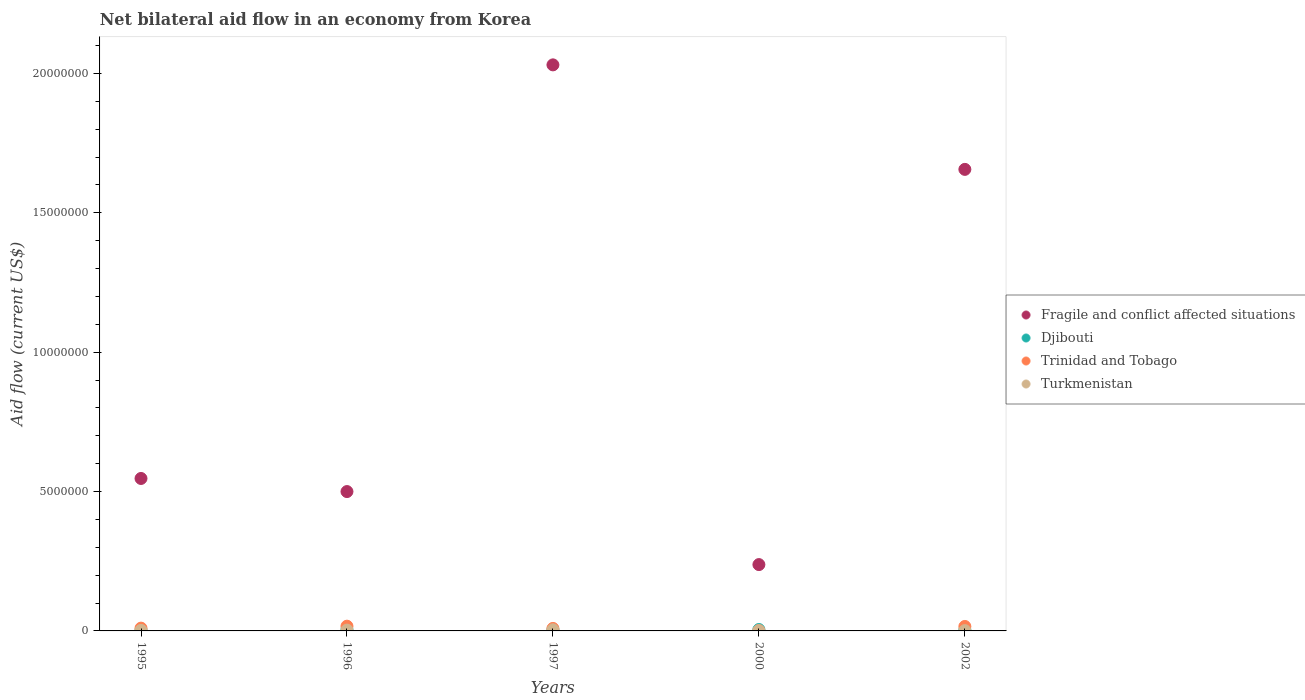How many different coloured dotlines are there?
Provide a succinct answer. 4. Across all years, what is the maximum net bilateral aid flow in Turkmenistan?
Keep it short and to the point. 4.00e+04. In which year was the net bilateral aid flow in Turkmenistan maximum?
Make the answer very short. 1997. What is the difference between the net bilateral aid flow in Fragile and conflict affected situations in 1995 and that in 2000?
Your answer should be compact. 3.09e+06. What is the average net bilateral aid flow in Fragile and conflict affected situations per year?
Provide a short and direct response. 9.94e+06. In the year 1997, what is the difference between the net bilateral aid flow in Djibouti and net bilateral aid flow in Fragile and conflict affected situations?
Your answer should be compact. -2.03e+07. In how many years, is the net bilateral aid flow in Trinidad and Tobago greater than 8000000 US$?
Give a very brief answer. 0. What is the difference between the highest and the second highest net bilateral aid flow in Djibouti?
Give a very brief answer. 0. What is the difference between the highest and the lowest net bilateral aid flow in Fragile and conflict affected situations?
Your answer should be compact. 1.79e+07. Is it the case that in every year, the sum of the net bilateral aid flow in Turkmenistan and net bilateral aid flow in Trinidad and Tobago  is greater than the sum of net bilateral aid flow in Fragile and conflict affected situations and net bilateral aid flow in Djibouti?
Your answer should be compact. No. Does the net bilateral aid flow in Trinidad and Tobago monotonically increase over the years?
Your answer should be very brief. No. Is the net bilateral aid flow in Trinidad and Tobago strictly greater than the net bilateral aid flow in Fragile and conflict affected situations over the years?
Give a very brief answer. No. How many years are there in the graph?
Provide a succinct answer. 5. Are the values on the major ticks of Y-axis written in scientific E-notation?
Ensure brevity in your answer.  No. Does the graph contain grids?
Keep it short and to the point. No. Where does the legend appear in the graph?
Your response must be concise. Center right. How many legend labels are there?
Make the answer very short. 4. How are the legend labels stacked?
Give a very brief answer. Vertical. What is the title of the graph?
Provide a short and direct response. Net bilateral aid flow in an economy from Korea. Does "Moldova" appear as one of the legend labels in the graph?
Your answer should be very brief. No. What is the label or title of the Y-axis?
Your response must be concise. Aid flow (current US$). What is the Aid flow (current US$) in Fragile and conflict affected situations in 1995?
Your response must be concise. 5.47e+06. What is the Aid flow (current US$) of Djibouti in 1995?
Offer a very short reply. 3.00e+04. What is the Aid flow (current US$) in Trinidad and Tobago in 1995?
Your answer should be very brief. 1.00e+05. What is the Aid flow (current US$) in Fragile and conflict affected situations in 1996?
Provide a short and direct response. 5.00e+06. What is the Aid flow (current US$) of Djibouti in 1996?
Make the answer very short. 5.00e+04. What is the Aid flow (current US$) in Fragile and conflict affected situations in 1997?
Offer a very short reply. 2.03e+07. What is the Aid flow (current US$) of Trinidad and Tobago in 1997?
Make the answer very short. 9.00e+04. What is the Aid flow (current US$) of Fragile and conflict affected situations in 2000?
Offer a very short reply. 2.38e+06. What is the Aid flow (current US$) in Fragile and conflict affected situations in 2002?
Your answer should be very brief. 1.66e+07. What is the Aid flow (current US$) in Djibouti in 2002?
Make the answer very short. 4.00e+04. What is the Aid flow (current US$) in Trinidad and Tobago in 2002?
Offer a very short reply. 1.60e+05. Across all years, what is the maximum Aid flow (current US$) in Fragile and conflict affected situations?
Give a very brief answer. 2.03e+07. Across all years, what is the maximum Aid flow (current US$) in Turkmenistan?
Your answer should be compact. 4.00e+04. Across all years, what is the minimum Aid flow (current US$) of Fragile and conflict affected situations?
Make the answer very short. 2.38e+06. Across all years, what is the minimum Aid flow (current US$) in Djibouti?
Offer a very short reply. 3.00e+04. Across all years, what is the minimum Aid flow (current US$) of Trinidad and Tobago?
Provide a succinct answer. 10000. Across all years, what is the minimum Aid flow (current US$) of Turkmenistan?
Your answer should be very brief. 10000. What is the total Aid flow (current US$) of Fragile and conflict affected situations in the graph?
Provide a short and direct response. 4.97e+07. What is the total Aid flow (current US$) of Trinidad and Tobago in the graph?
Offer a terse response. 5.30e+05. What is the difference between the Aid flow (current US$) of Fragile and conflict affected situations in 1995 and that in 1996?
Offer a very short reply. 4.70e+05. What is the difference between the Aid flow (current US$) of Djibouti in 1995 and that in 1996?
Give a very brief answer. -2.00e+04. What is the difference between the Aid flow (current US$) of Turkmenistan in 1995 and that in 1996?
Offer a very short reply. -10000. What is the difference between the Aid flow (current US$) of Fragile and conflict affected situations in 1995 and that in 1997?
Your answer should be compact. -1.48e+07. What is the difference between the Aid flow (current US$) in Djibouti in 1995 and that in 1997?
Make the answer very short. -10000. What is the difference between the Aid flow (current US$) of Fragile and conflict affected situations in 1995 and that in 2000?
Give a very brief answer. 3.09e+06. What is the difference between the Aid flow (current US$) of Djibouti in 1995 and that in 2000?
Give a very brief answer. -2.00e+04. What is the difference between the Aid flow (current US$) in Trinidad and Tobago in 1995 and that in 2000?
Your answer should be very brief. 9.00e+04. What is the difference between the Aid flow (current US$) of Fragile and conflict affected situations in 1995 and that in 2002?
Provide a short and direct response. -1.11e+07. What is the difference between the Aid flow (current US$) in Turkmenistan in 1995 and that in 2002?
Ensure brevity in your answer.  10000. What is the difference between the Aid flow (current US$) in Fragile and conflict affected situations in 1996 and that in 1997?
Ensure brevity in your answer.  -1.53e+07. What is the difference between the Aid flow (current US$) of Turkmenistan in 1996 and that in 1997?
Give a very brief answer. -10000. What is the difference between the Aid flow (current US$) in Fragile and conflict affected situations in 1996 and that in 2000?
Offer a very short reply. 2.62e+06. What is the difference between the Aid flow (current US$) of Trinidad and Tobago in 1996 and that in 2000?
Provide a succinct answer. 1.60e+05. What is the difference between the Aid flow (current US$) in Turkmenistan in 1996 and that in 2000?
Your answer should be very brief. 2.00e+04. What is the difference between the Aid flow (current US$) in Fragile and conflict affected situations in 1996 and that in 2002?
Provide a succinct answer. -1.16e+07. What is the difference between the Aid flow (current US$) of Djibouti in 1996 and that in 2002?
Your answer should be very brief. 10000. What is the difference between the Aid flow (current US$) in Trinidad and Tobago in 1996 and that in 2002?
Ensure brevity in your answer.  10000. What is the difference between the Aid flow (current US$) of Fragile and conflict affected situations in 1997 and that in 2000?
Your answer should be compact. 1.79e+07. What is the difference between the Aid flow (current US$) of Djibouti in 1997 and that in 2000?
Offer a terse response. -10000. What is the difference between the Aid flow (current US$) in Trinidad and Tobago in 1997 and that in 2000?
Your answer should be very brief. 8.00e+04. What is the difference between the Aid flow (current US$) in Fragile and conflict affected situations in 1997 and that in 2002?
Provide a succinct answer. 3.75e+06. What is the difference between the Aid flow (current US$) of Turkmenistan in 1997 and that in 2002?
Keep it short and to the point. 3.00e+04. What is the difference between the Aid flow (current US$) of Fragile and conflict affected situations in 2000 and that in 2002?
Make the answer very short. -1.42e+07. What is the difference between the Aid flow (current US$) of Djibouti in 2000 and that in 2002?
Keep it short and to the point. 10000. What is the difference between the Aid flow (current US$) of Turkmenistan in 2000 and that in 2002?
Provide a succinct answer. 0. What is the difference between the Aid flow (current US$) of Fragile and conflict affected situations in 1995 and the Aid flow (current US$) of Djibouti in 1996?
Your response must be concise. 5.42e+06. What is the difference between the Aid flow (current US$) of Fragile and conflict affected situations in 1995 and the Aid flow (current US$) of Trinidad and Tobago in 1996?
Offer a terse response. 5.30e+06. What is the difference between the Aid flow (current US$) of Fragile and conflict affected situations in 1995 and the Aid flow (current US$) of Turkmenistan in 1996?
Give a very brief answer. 5.44e+06. What is the difference between the Aid flow (current US$) of Fragile and conflict affected situations in 1995 and the Aid flow (current US$) of Djibouti in 1997?
Your answer should be compact. 5.43e+06. What is the difference between the Aid flow (current US$) of Fragile and conflict affected situations in 1995 and the Aid flow (current US$) of Trinidad and Tobago in 1997?
Provide a succinct answer. 5.38e+06. What is the difference between the Aid flow (current US$) of Fragile and conflict affected situations in 1995 and the Aid flow (current US$) of Turkmenistan in 1997?
Ensure brevity in your answer.  5.43e+06. What is the difference between the Aid flow (current US$) in Djibouti in 1995 and the Aid flow (current US$) in Trinidad and Tobago in 1997?
Your answer should be compact. -6.00e+04. What is the difference between the Aid flow (current US$) in Djibouti in 1995 and the Aid flow (current US$) in Turkmenistan in 1997?
Make the answer very short. -10000. What is the difference between the Aid flow (current US$) of Trinidad and Tobago in 1995 and the Aid flow (current US$) of Turkmenistan in 1997?
Provide a succinct answer. 6.00e+04. What is the difference between the Aid flow (current US$) in Fragile and conflict affected situations in 1995 and the Aid flow (current US$) in Djibouti in 2000?
Your answer should be compact. 5.42e+06. What is the difference between the Aid flow (current US$) of Fragile and conflict affected situations in 1995 and the Aid flow (current US$) of Trinidad and Tobago in 2000?
Give a very brief answer. 5.46e+06. What is the difference between the Aid flow (current US$) of Fragile and conflict affected situations in 1995 and the Aid flow (current US$) of Turkmenistan in 2000?
Give a very brief answer. 5.46e+06. What is the difference between the Aid flow (current US$) in Trinidad and Tobago in 1995 and the Aid flow (current US$) in Turkmenistan in 2000?
Make the answer very short. 9.00e+04. What is the difference between the Aid flow (current US$) in Fragile and conflict affected situations in 1995 and the Aid flow (current US$) in Djibouti in 2002?
Make the answer very short. 5.43e+06. What is the difference between the Aid flow (current US$) in Fragile and conflict affected situations in 1995 and the Aid flow (current US$) in Trinidad and Tobago in 2002?
Give a very brief answer. 5.31e+06. What is the difference between the Aid flow (current US$) of Fragile and conflict affected situations in 1995 and the Aid flow (current US$) of Turkmenistan in 2002?
Your response must be concise. 5.46e+06. What is the difference between the Aid flow (current US$) in Trinidad and Tobago in 1995 and the Aid flow (current US$) in Turkmenistan in 2002?
Make the answer very short. 9.00e+04. What is the difference between the Aid flow (current US$) in Fragile and conflict affected situations in 1996 and the Aid flow (current US$) in Djibouti in 1997?
Your response must be concise. 4.96e+06. What is the difference between the Aid flow (current US$) of Fragile and conflict affected situations in 1996 and the Aid flow (current US$) of Trinidad and Tobago in 1997?
Offer a terse response. 4.91e+06. What is the difference between the Aid flow (current US$) of Fragile and conflict affected situations in 1996 and the Aid flow (current US$) of Turkmenistan in 1997?
Provide a short and direct response. 4.96e+06. What is the difference between the Aid flow (current US$) in Djibouti in 1996 and the Aid flow (current US$) in Turkmenistan in 1997?
Provide a succinct answer. 10000. What is the difference between the Aid flow (current US$) of Fragile and conflict affected situations in 1996 and the Aid flow (current US$) of Djibouti in 2000?
Your answer should be very brief. 4.95e+06. What is the difference between the Aid flow (current US$) of Fragile and conflict affected situations in 1996 and the Aid flow (current US$) of Trinidad and Tobago in 2000?
Ensure brevity in your answer.  4.99e+06. What is the difference between the Aid flow (current US$) of Fragile and conflict affected situations in 1996 and the Aid flow (current US$) of Turkmenistan in 2000?
Ensure brevity in your answer.  4.99e+06. What is the difference between the Aid flow (current US$) of Djibouti in 1996 and the Aid flow (current US$) of Trinidad and Tobago in 2000?
Keep it short and to the point. 4.00e+04. What is the difference between the Aid flow (current US$) of Trinidad and Tobago in 1996 and the Aid flow (current US$) of Turkmenistan in 2000?
Make the answer very short. 1.60e+05. What is the difference between the Aid flow (current US$) of Fragile and conflict affected situations in 1996 and the Aid flow (current US$) of Djibouti in 2002?
Your response must be concise. 4.96e+06. What is the difference between the Aid flow (current US$) of Fragile and conflict affected situations in 1996 and the Aid flow (current US$) of Trinidad and Tobago in 2002?
Provide a succinct answer. 4.84e+06. What is the difference between the Aid flow (current US$) in Fragile and conflict affected situations in 1996 and the Aid flow (current US$) in Turkmenistan in 2002?
Ensure brevity in your answer.  4.99e+06. What is the difference between the Aid flow (current US$) in Djibouti in 1996 and the Aid flow (current US$) in Trinidad and Tobago in 2002?
Offer a very short reply. -1.10e+05. What is the difference between the Aid flow (current US$) of Djibouti in 1996 and the Aid flow (current US$) of Turkmenistan in 2002?
Make the answer very short. 4.00e+04. What is the difference between the Aid flow (current US$) of Trinidad and Tobago in 1996 and the Aid flow (current US$) of Turkmenistan in 2002?
Give a very brief answer. 1.60e+05. What is the difference between the Aid flow (current US$) in Fragile and conflict affected situations in 1997 and the Aid flow (current US$) in Djibouti in 2000?
Provide a succinct answer. 2.03e+07. What is the difference between the Aid flow (current US$) in Fragile and conflict affected situations in 1997 and the Aid flow (current US$) in Trinidad and Tobago in 2000?
Make the answer very short. 2.03e+07. What is the difference between the Aid flow (current US$) in Fragile and conflict affected situations in 1997 and the Aid flow (current US$) in Turkmenistan in 2000?
Offer a very short reply. 2.03e+07. What is the difference between the Aid flow (current US$) in Fragile and conflict affected situations in 1997 and the Aid flow (current US$) in Djibouti in 2002?
Give a very brief answer. 2.03e+07. What is the difference between the Aid flow (current US$) in Fragile and conflict affected situations in 1997 and the Aid flow (current US$) in Trinidad and Tobago in 2002?
Make the answer very short. 2.02e+07. What is the difference between the Aid flow (current US$) of Fragile and conflict affected situations in 1997 and the Aid flow (current US$) of Turkmenistan in 2002?
Offer a very short reply. 2.03e+07. What is the difference between the Aid flow (current US$) of Djibouti in 1997 and the Aid flow (current US$) of Trinidad and Tobago in 2002?
Ensure brevity in your answer.  -1.20e+05. What is the difference between the Aid flow (current US$) in Fragile and conflict affected situations in 2000 and the Aid flow (current US$) in Djibouti in 2002?
Your response must be concise. 2.34e+06. What is the difference between the Aid flow (current US$) of Fragile and conflict affected situations in 2000 and the Aid flow (current US$) of Trinidad and Tobago in 2002?
Keep it short and to the point. 2.22e+06. What is the difference between the Aid flow (current US$) of Fragile and conflict affected situations in 2000 and the Aid flow (current US$) of Turkmenistan in 2002?
Give a very brief answer. 2.37e+06. What is the difference between the Aid flow (current US$) of Djibouti in 2000 and the Aid flow (current US$) of Trinidad and Tobago in 2002?
Provide a succinct answer. -1.10e+05. What is the difference between the Aid flow (current US$) in Djibouti in 2000 and the Aid flow (current US$) in Turkmenistan in 2002?
Offer a terse response. 4.00e+04. What is the difference between the Aid flow (current US$) in Trinidad and Tobago in 2000 and the Aid flow (current US$) in Turkmenistan in 2002?
Provide a succinct answer. 0. What is the average Aid flow (current US$) in Fragile and conflict affected situations per year?
Offer a terse response. 9.94e+06. What is the average Aid flow (current US$) in Djibouti per year?
Offer a very short reply. 4.20e+04. What is the average Aid flow (current US$) in Trinidad and Tobago per year?
Offer a terse response. 1.06e+05. What is the average Aid flow (current US$) in Turkmenistan per year?
Ensure brevity in your answer.  2.20e+04. In the year 1995, what is the difference between the Aid flow (current US$) of Fragile and conflict affected situations and Aid flow (current US$) of Djibouti?
Make the answer very short. 5.44e+06. In the year 1995, what is the difference between the Aid flow (current US$) in Fragile and conflict affected situations and Aid flow (current US$) in Trinidad and Tobago?
Your answer should be very brief. 5.37e+06. In the year 1995, what is the difference between the Aid flow (current US$) of Fragile and conflict affected situations and Aid flow (current US$) of Turkmenistan?
Provide a short and direct response. 5.45e+06. In the year 1995, what is the difference between the Aid flow (current US$) in Djibouti and Aid flow (current US$) in Trinidad and Tobago?
Ensure brevity in your answer.  -7.00e+04. In the year 1996, what is the difference between the Aid flow (current US$) of Fragile and conflict affected situations and Aid flow (current US$) of Djibouti?
Provide a short and direct response. 4.95e+06. In the year 1996, what is the difference between the Aid flow (current US$) of Fragile and conflict affected situations and Aid flow (current US$) of Trinidad and Tobago?
Provide a short and direct response. 4.83e+06. In the year 1996, what is the difference between the Aid flow (current US$) of Fragile and conflict affected situations and Aid flow (current US$) of Turkmenistan?
Your response must be concise. 4.97e+06. In the year 1996, what is the difference between the Aid flow (current US$) of Djibouti and Aid flow (current US$) of Turkmenistan?
Provide a short and direct response. 2.00e+04. In the year 1997, what is the difference between the Aid flow (current US$) in Fragile and conflict affected situations and Aid flow (current US$) in Djibouti?
Make the answer very short. 2.03e+07. In the year 1997, what is the difference between the Aid flow (current US$) in Fragile and conflict affected situations and Aid flow (current US$) in Trinidad and Tobago?
Ensure brevity in your answer.  2.02e+07. In the year 1997, what is the difference between the Aid flow (current US$) of Fragile and conflict affected situations and Aid flow (current US$) of Turkmenistan?
Keep it short and to the point. 2.03e+07. In the year 1997, what is the difference between the Aid flow (current US$) in Djibouti and Aid flow (current US$) in Trinidad and Tobago?
Your response must be concise. -5.00e+04. In the year 1997, what is the difference between the Aid flow (current US$) in Djibouti and Aid flow (current US$) in Turkmenistan?
Your answer should be very brief. 0. In the year 2000, what is the difference between the Aid flow (current US$) of Fragile and conflict affected situations and Aid flow (current US$) of Djibouti?
Offer a terse response. 2.33e+06. In the year 2000, what is the difference between the Aid flow (current US$) of Fragile and conflict affected situations and Aid flow (current US$) of Trinidad and Tobago?
Make the answer very short. 2.37e+06. In the year 2000, what is the difference between the Aid flow (current US$) of Fragile and conflict affected situations and Aid flow (current US$) of Turkmenistan?
Your answer should be very brief. 2.37e+06. In the year 2000, what is the difference between the Aid flow (current US$) of Djibouti and Aid flow (current US$) of Trinidad and Tobago?
Keep it short and to the point. 4.00e+04. In the year 2002, what is the difference between the Aid flow (current US$) of Fragile and conflict affected situations and Aid flow (current US$) of Djibouti?
Ensure brevity in your answer.  1.65e+07. In the year 2002, what is the difference between the Aid flow (current US$) of Fragile and conflict affected situations and Aid flow (current US$) of Trinidad and Tobago?
Your answer should be very brief. 1.64e+07. In the year 2002, what is the difference between the Aid flow (current US$) of Fragile and conflict affected situations and Aid flow (current US$) of Turkmenistan?
Ensure brevity in your answer.  1.66e+07. In the year 2002, what is the difference between the Aid flow (current US$) of Djibouti and Aid flow (current US$) of Trinidad and Tobago?
Your response must be concise. -1.20e+05. In the year 2002, what is the difference between the Aid flow (current US$) in Djibouti and Aid flow (current US$) in Turkmenistan?
Ensure brevity in your answer.  3.00e+04. In the year 2002, what is the difference between the Aid flow (current US$) of Trinidad and Tobago and Aid flow (current US$) of Turkmenistan?
Make the answer very short. 1.50e+05. What is the ratio of the Aid flow (current US$) in Fragile and conflict affected situations in 1995 to that in 1996?
Your answer should be compact. 1.09. What is the ratio of the Aid flow (current US$) of Trinidad and Tobago in 1995 to that in 1996?
Your answer should be compact. 0.59. What is the ratio of the Aid flow (current US$) of Fragile and conflict affected situations in 1995 to that in 1997?
Give a very brief answer. 0.27. What is the ratio of the Aid flow (current US$) of Djibouti in 1995 to that in 1997?
Provide a succinct answer. 0.75. What is the ratio of the Aid flow (current US$) in Turkmenistan in 1995 to that in 1997?
Offer a very short reply. 0.5. What is the ratio of the Aid flow (current US$) in Fragile and conflict affected situations in 1995 to that in 2000?
Ensure brevity in your answer.  2.3. What is the ratio of the Aid flow (current US$) of Djibouti in 1995 to that in 2000?
Make the answer very short. 0.6. What is the ratio of the Aid flow (current US$) in Trinidad and Tobago in 1995 to that in 2000?
Offer a terse response. 10. What is the ratio of the Aid flow (current US$) of Fragile and conflict affected situations in 1995 to that in 2002?
Give a very brief answer. 0.33. What is the ratio of the Aid flow (current US$) of Djibouti in 1995 to that in 2002?
Your answer should be compact. 0.75. What is the ratio of the Aid flow (current US$) of Turkmenistan in 1995 to that in 2002?
Offer a very short reply. 2. What is the ratio of the Aid flow (current US$) in Fragile and conflict affected situations in 1996 to that in 1997?
Your answer should be very brief. 0.25. What is the ratio of the Aid flow (current US$) of Djibouti in 1996 to that in 1997?
Ensure brevity in your answer.  1.25. What is the ratio of the Aid flow (current US$) in Trinidad and Tobago in 1996 to that in 1997?
Your response must be concise. 1.89. What is the ratio of the Aid flow (current US$) in Fragile and conflict affected situations in 1996 to that in 2000?
Your response must be concise. 2.1. What is the ratio of the Aid flow (current US$) in Djibouti in 1996 to that in 2000?
Your response must be concise. 1. What is the ratio of the Aid flow (current US$) in Fragile and conflict affected situations in 1996 to that in 2002?
Your answer should be very brief. 0.3. What is the ratio of the Aid flow (current US$) of Djibouti in 1996 to that in 2002?
Provide a succinct answer. 1.25. What is the ratio of the Aid flow (current US$) of Trinidad and Tobago in 1996 to that in 2002?
Make the answer very short. 1.06. What is the ratio of the Aid flow (current US$) in Fragile and conflict affected situations in 1997 to that in 2000?
Provide a succinct answer. 8.53. What is the ratio of the Aid flow (current US$) in Turkmenistan in 1997 to that in 2000?
Ensure brevity in your answer.  4. What is the ratio of the Aid flow (current US$) of Fragile and conflict affected situations in 1997 to that in 2002?
Provide a succinct answer. 1.23. What is the ratio of the Aid flow (current US$) of Djibouti in 1997 to that in 2002?
Provide a succinct answer. 1. What is the ratio of the Aid flow (current US$) of Trinidad and Tobago in 1997 to that in 2002?
Your answer should be very brief. 0.56. What is the ratio of the Aid flow (current US$) in Turkmenistan in 1997 to that in 2002?
Provide a short and direct response. 4. What is the ratio of the Aid flow (current US$) of Fragile and conflict affected situations in 2000 to that in 2002?
Your answer should be compact. 0.14. What is the ratio of the Aid flow (current US$) of Djibouti in 2000 to that in 2002?
Your answer should be compact. 1.25. What is the ratio of the Aid flow (current US$) in Trinidad and Tobago in 2000 to that in 2002?
Your answer should be very brief. 0.06. What is the ratio of the Aid flow (current US$) of Turkmenistan in 2000 to that in 2002?
Provide a short and direct response. 1. What is the difference between the highest and the second highest Aid flow (current US$) in Fragile and conflict affected situations?
Provide a succinct answer. 3.75e+06. What is the difference between the highest and the second highest Aid flow (current US$) of Djibouti?
Make the answer very short. 0. What is the difference between the highest and the second highest Aid flow (current US$) in Trinidad and Tobago?
Your answer should be compact. 10000. What is the difference between the highest and the lowest Aid flow (current US$) in Fragile and conflict affected situations?
Provide a succinct answer. 1.79e+07. What is the difference between the highest and the lowest Aid flow (current US$) in Djibouti?
Give a very brief answer. 2.00e+04. What is the difference between the highest and the lowest Aid flow (current US$) in Trinidad and Tobago?
Keep it short and to the point. 1.60e+05. What is the difference between the highest and the lowest Aid flow (current US$) in Turkmenistan?
Offer a very short reply. 3.00e+04. 